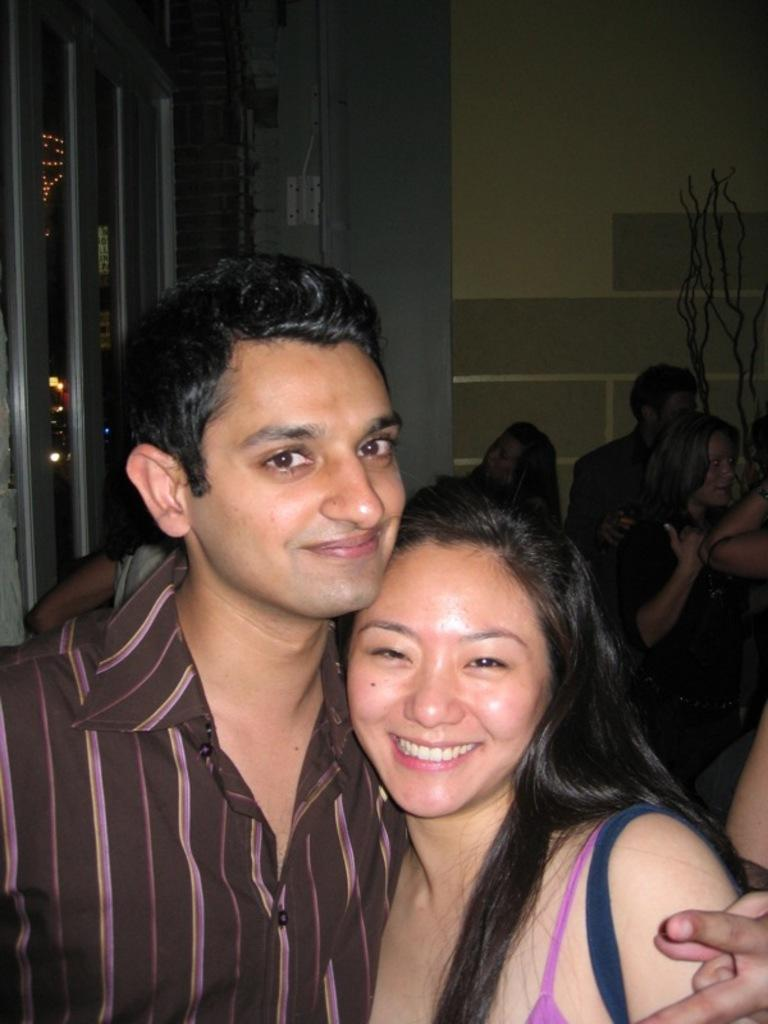Who are the people in the image? There is a man and a woman in the image. What are the man and woman doing in the image? The man and woman are standing and smiling. What can be seen on the left side of the image? There are poles on the left side of the image. What is present in the background of the image? There is a wall in the image. How many groups of people can be seen in the image? There are groups of people standing in the image. What type of chain can be seen hanging from the man's neck in the image? There is no chain visible around the man's neck in the image. How many snails are crawling on the wall in the image? There are no snails present in the image; the wall is clear of any snails. 